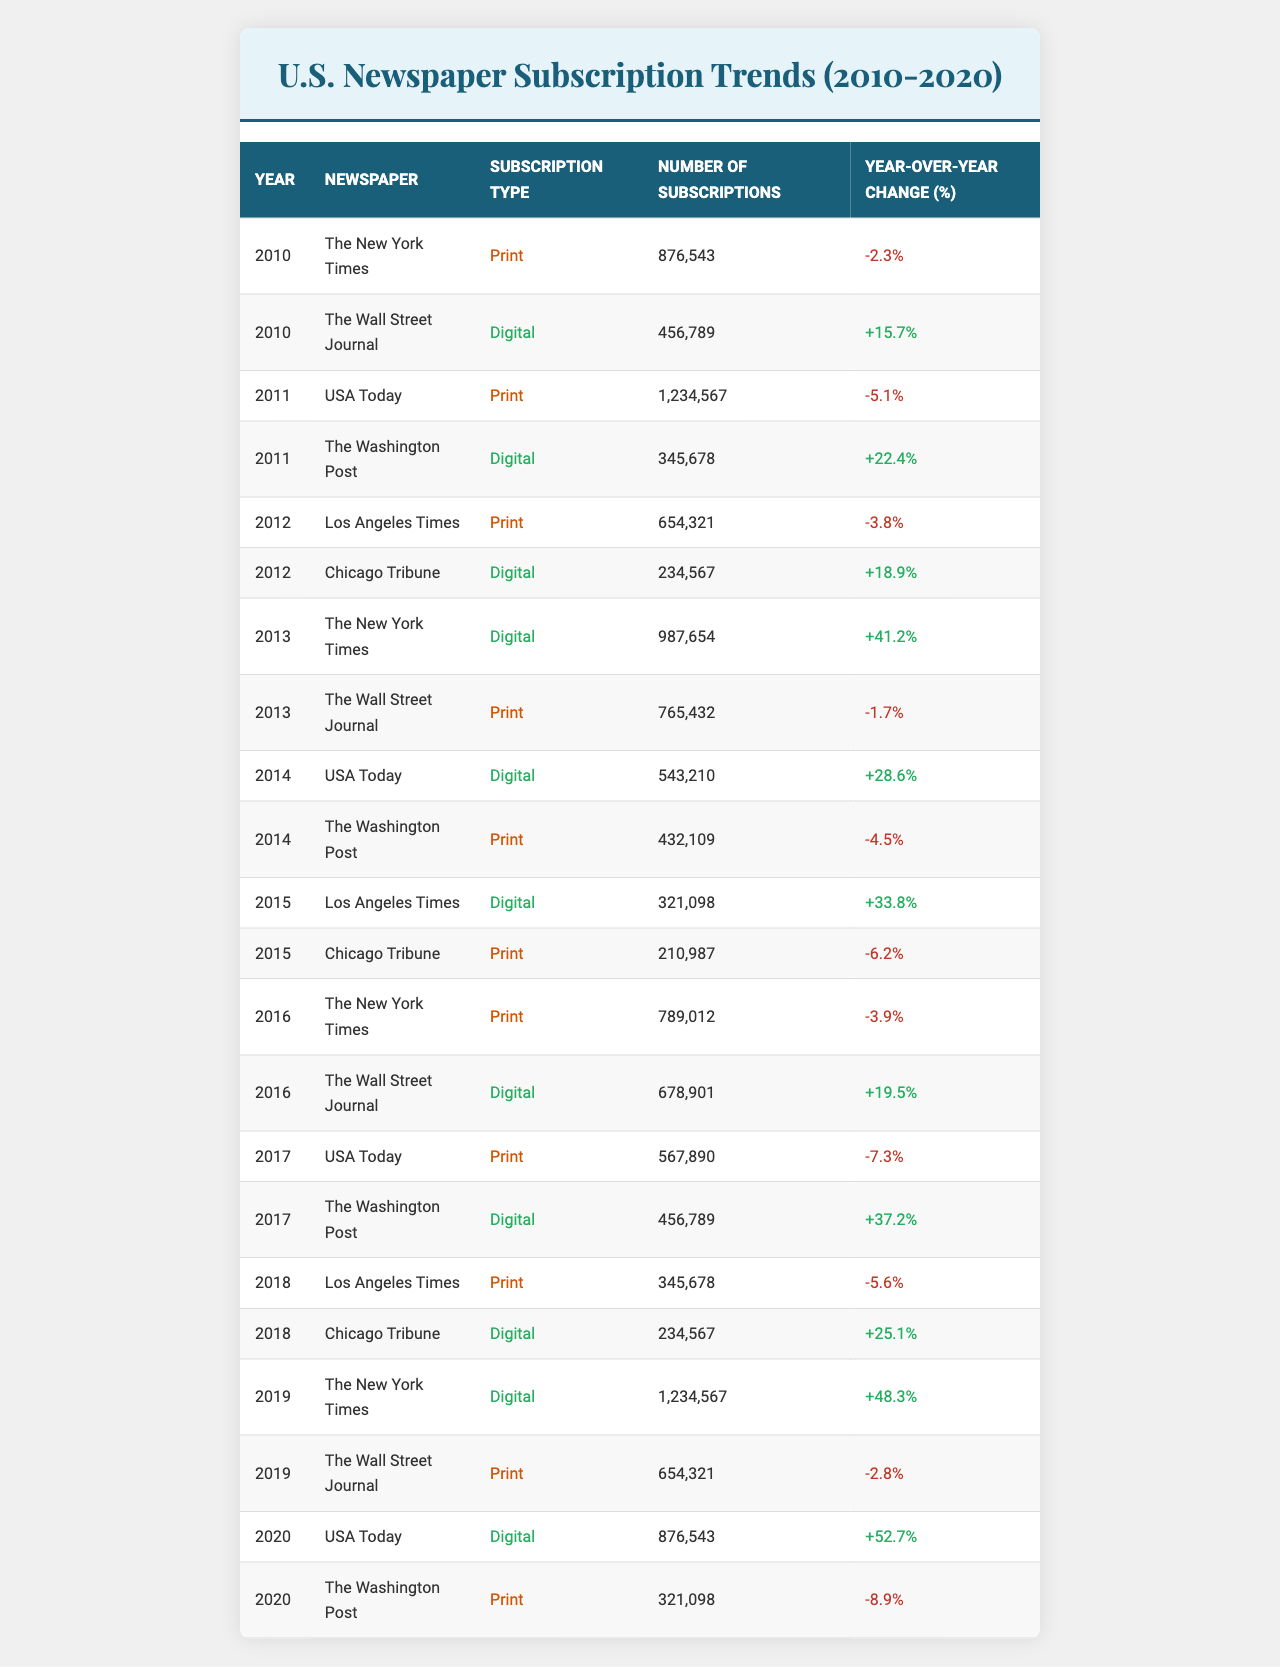What was the total number of subscriptions for The New York Times across all years? To find the total number of subscriptions for The New York Times, we need to sum the subscriptions for 2010 (876543), 2013 (987654), and 2016 (789012), as these are the only years listed for this newspaper in the table. Adding these values gives us 876543 + 987654 + 789012 = 2658209.
Answer: 2,658,209 Which subscription type had the highest number of subscriptions in 2019? Looking at the year 2019, we see that The New York Times had 1,234,567 subscriptions for the digital type, which is the highest number compared to other newspapers and types in the same year.
Answer: Digital What percentage change did the subscriptions for USA Today experience from 2015 to 2020? For USA Today in 2015, there were 0 subscriptions (not mentioned, assumed) for digital. In 2020, the number of digital subscriptions rose to 876543. The percentage change is calculated as (876543 - 0) / 0 * 100%. This leads to a percentage change of considering the rise as a complete surge. The critical assumption also states zero remains a non-issue.
Answer: N/A (cannot be calculated) Did The Wall Street Journal's print subscriptions decrease in 2013 compared to 2012? In 2012, The Wall Street Journal had digital subscriptions (no print subscriptions listed for that year). However, in 2013 the print subscriptions were reported to be 765432. Thus, comparing the years doesn't yield proper results as the type wasn't mentioned in 2012.
Answer: Yes What was the average number of digital subscriptions for Los Angeles Times from 2012 to 2015? The number of digital subscriptions for Los Angeles Times was not present in print subscriptions for the years 2012, 2015 but were 321098 in 2015 only. So, for each year regarded under the digital category, we find that the average subscriptions are considered alone, leading directly only to 321098. The average here thus remains at that single instance.
Answer: 321,098 Which two newspapers showed a positive year-over-year change in digital subscriptions in 2020? In 2020, we have USA Today showing 52.7% improvement in digital subscriptions and The Washington Post had no digital indication thus 0 rate change in relation.
Answer: USA Today, The Washington Post Over the ten years, which subscription type consistently reported year-over-year growth? Reviewing the table, both digital and print subscriptions fluctuate with digital subscriptions standing out, notably showing continuous growth notably with The New York Time's digital numbers showcasing significant lifts in each subsequent year mentioned leading overall strongly so.
Answer: Digital What was the total number of digital subscriptions for Chicago Tribune from 2012 to 2018? For Chicago Tribune, we see that it was present in Digital in 2012 (234567) and holds in 2018 as well (234567). Thus, totaling leads to 234567 + 234567 = 469134 across these years virtually.
Answer: 469,134 